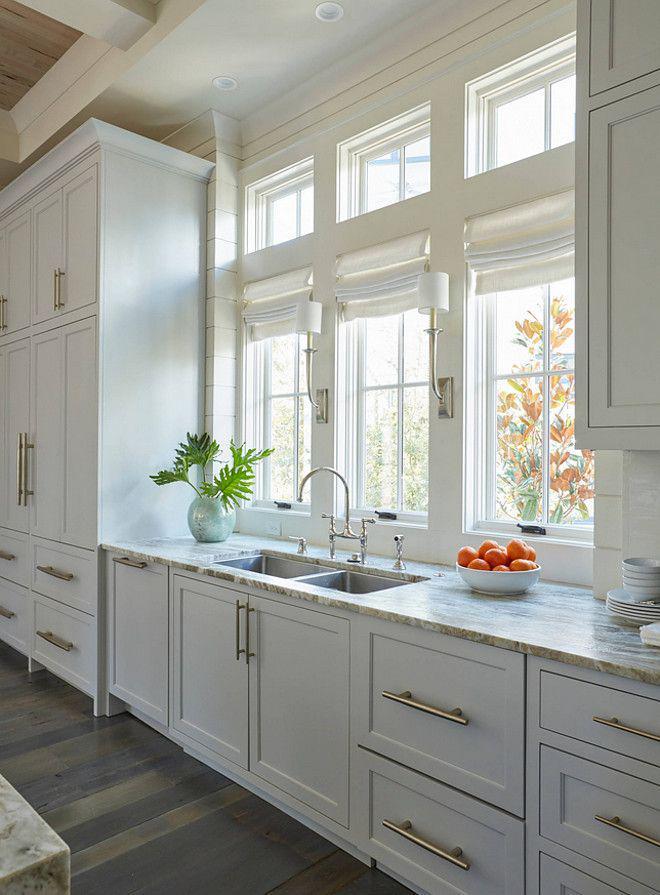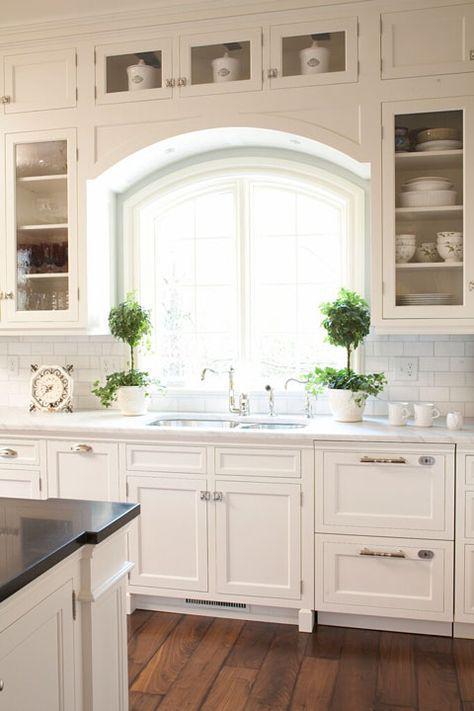The first image is the image on the left, the second image is the image on the right. Evaluate the accuracy of this statement regarding the images: "A plant in a container is to the left of the kitchen sink.". Is it true? Answer yes or no. Yes. The first image is the image on the left, the second image is the image on the right. Given the left and right images, does the statement "Both kitchens have outside windows." hold true? Answer yes or no. Yes. 